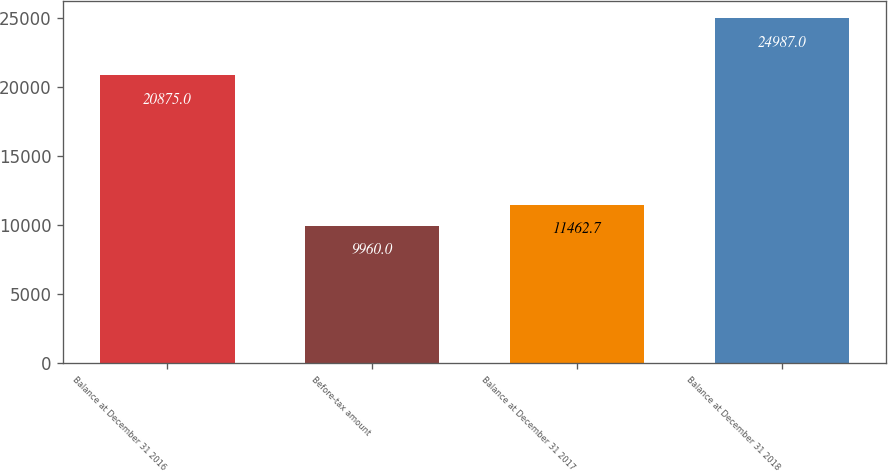Convert chart. <chart><loc_0><loc_0><loc_500><loc_500><bar_chart><fcel>Balance at December 31 2016<fcel>Before-tax amount<fcel>Balance at December 31 2017<fcel>Balance at December 31 2018<nl><fcel>20875<fcel>9960<fcel>11462.7<fcel>24987<nl></chart> 